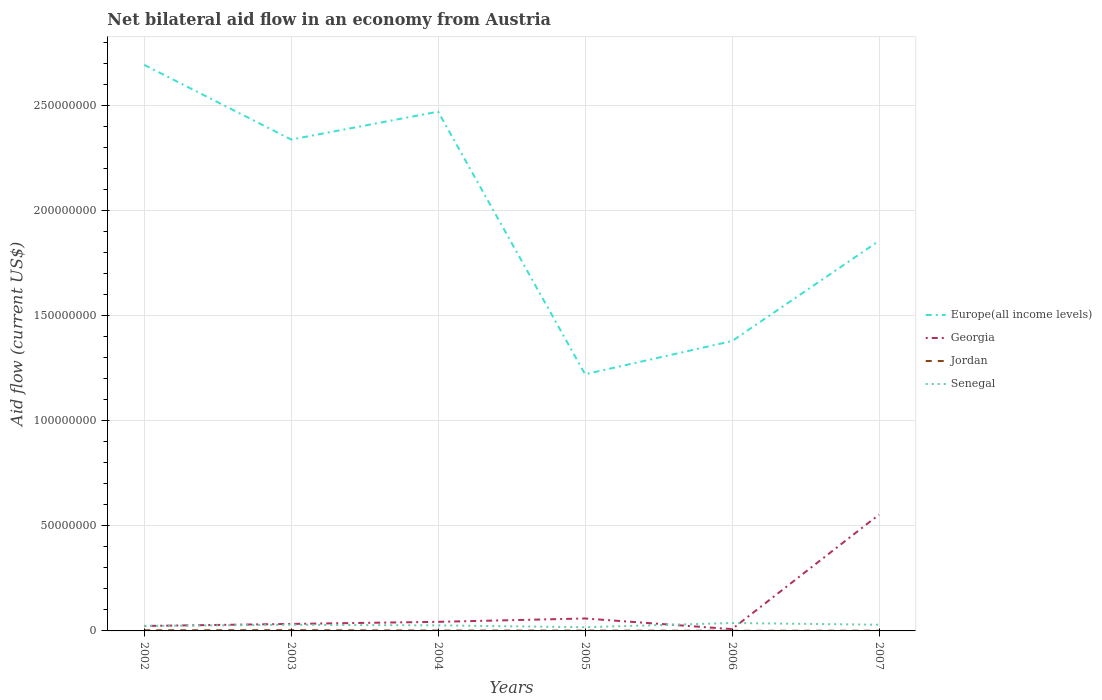Is the number of lines equal to the number of legend labels?
Your answer should be very brief. Yes. Across all years, what is the maximum net bilateral aid flow in Georgia?
Provide a short and direct response. 8.60e+05. In which year was the net bilateral aid flow in Jordan maximum?
Offer a very short reply. 2006. What is the total net bilateral aid flow in Jordan in the graph?
Keep it short and to the point. 2.10e+05. What is the difference between the highest and the second highest net bilateral aid flow in Georgia?
Make the answer very short. 5.44e+07. How many years are there in the graph?
Offer a terse response. 6. Does the graph contain grids?
Make the answer very short. Yes. What is the title of the graph?
Offer a terse response. Net bilateral aid flow in an economy from Austria. What is the Aid flow (current US$) in Europe(all income levels) in 2002?
Offer a very short reply. 2.69e+08. What is the Aid flow (current US$) of Georgia in 2002?
Your response must be concise. 2.36e+06. What is the Aid flow (current US$) in Jordan in 2002?
Make the answer very short. 3.10e+05. What is the Aid flow (current US$) in Senegal in 2002?
Your answer should be very brief. 2.36e+06. What is the Aid flow (current US$) in Europe(all income levels) in 2003?
Your response must be concise. 2.34e+08. What is the Aid flow (current US$) in Georgia in 2003?
Make the answer very short. 3.33e+06. What is the Aid flow (current US$) in Senegal in 2003?
Give a very brief answer. 2.93e+06. What is the Aid flow (current US$) of Europe(all income levels) in 2004?
Keep it short and to the point. 2.47e+08. What is the Aid flow (current US$) in Georgia in 2004?
Provide a succinct answer. 4.32e+06. What is the Aid flow (current US$) in Senegal in 2004?
Provide a succinct answer. 2.63e+06. What is the Aid flow (current US$) of Europe(all income levels) in 2005?
Make the answer very short. 1.22e+08. What is the Aid flow (current US$) of Georgia in 2005?
Keep it short and to the point. 5.92e+06. What is the Aid flow (current US$) in Senegal in 2005?
Provide a short and direct response. 1.77e+06. What is the Aid flow (current US$) in Europe(all income levels) in 2006?
Give a very brief answer. 1.38e+08. What is the Aid flow (current US$) in Georgia in 2006?
Keep it short and to the point. 8.60e+05. What is the Aid flow (current US$) of Jordan in 2006?
Offer a terse response. 7.00e+04. What is the Aid flow (current US$) of Senegal in 2006?
Your response must be concise. 3.77e+06. What is the Aid flow (current US$) of Europe(all income levels) in 2007?
Make the answer very short. 1.86e+08. What is the Aid flow (current US$) in Georgia in 2007?
Ensure brevity in your answer.  5.53e+07. What is the Aid flow (current US$) of Jordan in 2007?
Keep it short and to the point. 1.00e+05. What is the Aid flow (current US$) in Senegal in 2007?
Offer a very short reply. 2.94e+06. Across all years, what is the maximum Aid flow (current US$) of Europe(all income levels)?
Give a very brief answer. 2.69e+08. Across all years, what is the maximum Aid flow (current US$) in Georgia?
Provide a succinct answer. 5.53e+07. Across all years, what is the maximum Aid flow (current US$) of Senegal?
Offer a terse response. 3.77e+06. Across all years, what is the minimum Aid flow (current US$) of Europe(all income levels)?
Make the answer very short. 1.22e+08. Across all years, what is the minimum Aid flow (current US$) of Georgia?
Offer a very short reply. 8.60e+05. Across all years, what is the minimum Aid flow (current US$) of Jordan?
Provide a short and direct response. 7.00e+04. Across all years, what is the minimum Aid flow (current US$) of Senegal?
Your answer should be very brief. 1.77e+06. What is the total Aid flow (current US$) in Europe(all income levels) in the graph?
Provide a succinct answer. 1.20e+09. What is the total Aid flow (current US$) of Georgia in the graph?
Your answer should be compact. 7.21e+07. What is the total Aid flow (current US$) in Jordan in the graph?
Your answer should be compact. 1.17e+06. What is the total Aid flow (current US$) in Senegal in the graph?
Provide a short and direct response. 1.64e+07. What is the difference between the Aid flow (current US$) in Europe(all income levels) in 2002 and that in 2003?
Your response must be concise. 3.55e+07. What is the difference between the Aid flow (current US$) in Georgia in 2002 and that in 2003?
Provide a short and direct response. -9.70e+05. What is the difference between the Aid flow (current US$) of Senegal in 2002 and that in 2003?
Provide a short and direct response. -5.70e+05. What is the difference between the Aid flow (current US$) in Europe(all income levels) in 2002 and that in 2004?
Offer a terse response. 2.23e+07. What is the difference between the Aid flow (current US$) in Georgia in 2002 and that in 2004?
Provide a short and direct response. -1.96e+06. What is the difference between the Aid flow (current US$) in Senegal in 2002 and that in 2004?
Offer a very short reply. -2.70e+05. What is the difference between the Aid flow (current US$) in Europe(all income levels) in 2002 and that in 2005?
Offer a terse response. 1.47e+08. What is the difference between the Aid flow (current US$) of Georgia in 2002 and that in 2005?
Your response must be concise. -3.56e+06. What is the difference between the Aid flow (current US$) in Jordan in 2002 and that in 2005?
Your answer should be compact. 1.60e+05. What is the difference between the Aid flow (current US$) of Senegal in 2002 and that in 2005?
Your answer should be compact. 5.90e+05. What is the difference between the Aid flow (current US$) in Europe(all income levels) in 2002 and that in 2006?
Your answer should be very brief. 1.31e+08. What is the difference between the Aid flow (current US$) of Georgia in 2002 and that in 2006?
Provide a succinct answer. 1.50e+06. What is the difference between the Aid flow (current US$) of Senegal in 2002 and that in 2006?
Keep it short and to the point. -1.41e+06. What is the difference between the Aid flow (current US$) in Europe(all income levels) in 2002 and that in 2007?
Make the answer very short. 8.37e+07. What is the difference between the Aid flow (current US$) in Georgia in 2002 and that in 2007?
Give a very brief answer. -5.29e+07. What is the difference between the Aid flow (current US$) in Jordan in 2002 and that in 2007?
Ensure brevity in your answer.  2.10e+05. What is the difference between the Aid flow (current US$) in Senegal in 2002 and that in 2007?
Give a very brief answer. -5.80e+05. What is the difference between the Aid flow (current US$) of Europe(all income levels) in 2003 and that in 2004?
Provide a succinct answer. -1.32e+07. What is the difference between the Aid flow (current US$) in Georgia in 2003 and that in 2004?
Give a very brief answer. -9.90e+05. What is the difference between the Aid flow (current US$) of Europe(all income levels) in 2003 and that in 2005?
Offer a very short reply. 1.12e+08. What is the difference between the Aid flow (current US$) of Georgia in 2003 and that in 2005?
Offer a very short reply. -2.59e+06. What is the difference between the Aid flow (current US$) of Jordan in 2003 and that in 2005?
Your answer should be compact. 2.10e+05. What is the difference between the Aid flow (current US$) of Senegal in 2003 and that in 2005?
Your answer should be very brief. 1.16e+06. What is the difference between the Aid flow (current US$) of Europe(all income levels) in 2003 and that in 2006?
Ensure brevity in your answer.  9.59e+07. What is the difference between the Aid flow (current US$) of Georgia in 2003 and that in 2006?
Keep it short and to the point. 2.47e+06. What is the difference between the Aid flow (current US$) in Senegal in 2003 and that in 2006?
Provide a succinct answer. -8.40e+05. What is the difference between the Aid flow (current US$) of Europe(all income levels) in 2003 and that in 2007?
Your response must be concise. 4.82e+07. What is the difference between the Aid flow (current US$) in Georgia in 2003 and that in 2007?
Provide a short and direct response. -5.20e+07. What is the difference between the Aid flow (current US$) in Senegal in 2003 and that in 2007?
Give a very brief answer. -10000. What is the difference between the Aid flow (current US$) in Europe(all income levels) in 2004 and that in 2005?
Offer a very short reply. 1.25e+08. What is the difference between the Aid flow (current US$) in Georgia in 2004 and that in 2005?
Your answer should be very brief. -1.60e+06. What is the difference between the Aid flow (current US$) of Jordan in 2004 and that in 2005?
Your answer should be compact. 3.00e+04. What is the difference between the Aid flow (current US$) of Senegal in 2004 and that in 2005?
Your answer should be compact. 8.60e+05. What is the difference between the Aid flow (current US$) in Europe(all income levels) in 2004 and that in 2006?
Give a very brief answer. 1.09e+08. What is the difference between the Aid flow (current US$) in Georgia in 2004 and that in 2006?
Provide a short and direct response. 3.46e+06. What is the difference between the Aid flow (current US$) of Senegal in 2004 and that in 2006?
Provide a succinct answer. -1.14e+06. What is the difference between the Aid flow (current US$) in Europe(all income levels) in 2004 and that in 2007?
Offer a terse response. 6.15e+07. What is the difference between the Aid flow (current US$) of Georgia in 2004 and that in 2007?
Provide a succinct answer. -5.10e+07. What is the difference between the Aid flow (current US$) of Jordan in 2004 and that in 2007?
Ensure brevity in your answer.  8.00e+04. What is the difference between the Aid flow (current US$) of Senegal in 2004 and that in 2007?
Your answer should be very brief. -3.10e+05. What is the difference between the Aid flow (current US$) in Europe(all income levels) in 2005 and that in 2006?
Offer a terse response. -1.58e+07. What is the difference between the Aid flow (current US$) in Georgia in 2005 and that in 2006?
Keep it short and to the point. 5.06e+06. What is the difference between the Aid flow (current US$) in Europe(all income levels) in 2005 and that in 2007?
Your answer should be very brief. -6.34e+07. What is the difference between the Aid flow (current US$) of Georgia in 2005 and that in 2007?
Give a very brief answer. -4.94e+07. What is the difference between the Aid flow (current US$) in Jordan in 2005 and that in 2007?
Give a very brief answer. 5.00e+04. What is the difference between the Aid flow (current US$) in Senegal in 2005 and that in 2007?
Give a very brief answer. -1.17e+06. What is the difference between the Aid flow (current US$) in Europe(all income levels) in 2006 and that in 2007?
Offer a terse response. -4.76e+07. What is the difference between the Aid flow (current US$) of Georgia in 2006 and that in 2007?
Give a very brief answer. -5.44e+07. What is the difference between the Aid flow (current US$) of Jordan in 2006 and that in 2007?
Your response must be concise. -3.00e+04. What is the difference between the Aid flow (current US$) of Senegal in 2006 and that in 2007?
Your response must be concise. 8.30e+05. What is the difference between the Aid flow (current US$) in Europe(all income levels) in 2002 and the Aid flow (current US$) in Georgia in 2003?
Give a very brief answer. 2.66e+08. What is the difference between the Aid flow (current US$) in Europe(all income levels) in 2002 and the Aid flow (current US$) in Jordan in 2003?
Offer a terse response. 2.69e+08. What is the difference between the Aid flow (current US$) in Europe(all income levels) in 2002 and the Aid flow (current US$) in Senegal in 2003?
Provide a short and direct response. 2.66e+08. What is the difference between the Aid flow (current US$) of Georgia in 2002 and the Aid flow (current US$) of Senegal in 2003?
Make the answer very short. -5.70e+05. What is the difference between the Aid flow (current US$) in Jordan in 2002 and the Aid flow (current US$) in Senegal in 2003?
Your response must be concise. -2.62e+06. What is the difference between the Aid flow (current US$) in Europe(all income levels) in 2002 and the Aid flow (current US$) in Georgia in 2004?
Offer a very short reply. 2.65e+08. What is the difference between the Aid flow (current US$) of Europe(all income levels) in 2002 and the Aid flow (current US$) of Jordan in 2004?
Provide a succinct answer. 2.69e+08. What is the difference between the Aid flow (current US$) of Europe(all income levels) in 2002 and the Aid flow (current US$) of Senegal in 2004?
Offer a very short reply. 2.67e+08. What is the difference between the Aid flow (current US$) of Georgia in 2002 and the Aid flow (current US$) of Jordan in 2004?
Your response must be concise. 2.18e+06. What is the difference between the Aid flow (current US$) of Jordan in 2002 and the Aid flow (current US$) of Senegal in 2004?
Make the answer very short. -2.32e+06. What is the difference between the Aid flow (current US$) of Europe(all income levels) in 2002 and the Aid flow (current US$) of Georgia in 2005?
Your answer should be very brief. 2.63e+08. What is the difference between the Aid flow (current US$) in Europe(all income levels) in 2002 and the Aid flow (current US$) in Jordan in 2005?
Keep it short and to the point. 2.69e+08. What is the difference between the Aid flow (current US$) of Europe(all income levels) in 2002 and the Aid flow (current US$) of Senegal in 2005?
Make the answer very short. 2.67e+08. What is the difference between the Aid flow (current US$) in Georgia in 2002 and the Aid flow (current US$) in Jordan in 2005?
Your answer should be compact. 2.21e+06. What is the difference between the Aid flow (current US$) of Georgia in 2002 and the Aid flow (current US$) of Senegal in 2005?
Ensure brevity in your answer.  5.90e+05. What is the difference between the Aid flow (current US$) of Jordan in 2002 and the Aid flow (current US$) of Senegal in 2005?
Keep it short and to the point. -1.46e+06. What is the difference between the Aid flow (current US$) of Europe(all income levels) in 2002 and the Aid flow (current US$) of Georgia in 2006?
Ensure brevity in your answer.  2.68e+08. What is the difference between the Aid flow (current US$) in Europe(all income levels) in 2002 and the Aid flow (current US$) in Jordan in 2006?
Ensure brevity in your answer.  2.69e+08. What is the difference between the Aid flow (current US$) in Europe(all income levels) in 2002 and the Aid flow (current US$) in Senegal in 2006?
Offer a very short reply. 2.65e+08. What is the difference between the Aid flow (current US$) in Georgia in 2002 and the Aid flow (current US$) in Jordan in 2006?
Make the answer very short. 2.29e+06. What is the difference between the Aid flow (current US$) of Georgia in 2002 and the Aid flow (current US$) of Senegal in 2006?
Make the answer very short. -1.41e+06. What is the difference between the Aid flow (current US$) in Jordan in 2002 and the Aid flow (current US$) in Senegal in 2006?
Your answer should be very brief. -3.46e+06. What is the difference between the Aid flow (current US$) of Europe(all income levels) in 2002 and the Aid flow (current US$) of Georgia in 2007?
Keep it short and to the point. 2.14e+08. What is the difference between the Aid flow (current US$) in Europe(all income levels) in 2002 and the Aid flow (current US$) in Jordan in 2007?
Give a very brief answer. 2.69e+08. What is the difference between the Aid flow (current US$) of Europe(all income levels) in 2002 and the Aid flow (current US$) of Senegal in 2007?
Your response must be concise. 2.66e+08. What is the difference between the Aid flow (current US$) in Georgia in 2002 and the Aid flow (current US$) in Jordan in 2007?
Make the answer very short. 2.26e+06. What is the difference between the Aid flow (current US$) of Georgia in 2002 and the Aid flow (current US$) of Senegal in 2007?
Give a very brief answer. -5.80e+05. What is the difference between the Aid flow (current US$) in Jordan in 2002 and the Aid flow (current US$) in Senegal in 2007?
Make the answer very short. -2.63e+06. What is the difference between the Aid flow (current US$) of Europe(all income levels) in 2003 and the Aid flow (current US$) of Georgia in 2004?
Ensure brevity in your answer.  2.29e+08. What is the difference between the Aid flow (current US$) of Europe(all income levels) in 2003 and the Aid flow (current US$) of Jordan in 2004?
Ensure brevity in your answer.  2.34e+08. What is the difference between the Aid flow (current US$) in Europe(all income levels) in 2003 and the Aid flow (current US$) in Senegal in 2004?
Provide a succinct answer. 2.31e+08. What is the difference between the Aid flow (current US$) in Georgia in 2003 and the Aid flow (current US$) in Jordan in 2004?
Keep it short and to the point. 3.15e+06. What is the difference between the Aid flow (current US$) of Jordan in 2003 and the Aid flow (current US$) of Senegal in 2004?
Your answer should be very brief. -2.27e+06. What is the difference between the Aid flow (current US$) of Europe(all income levels) in 2003 and the Aid flow (current US$) of Georgia in 2005?
Give a very brief answer. 2.28e+08. What is the difference between the Aid flow (current US$) of Europe(all income levels) in 2003 and the Aid flow (current US$) of Jordan in 2005?
Make the answer very short. 2.34e+08. What is the difference between the Aid flow (current US$) in Europe(all income levels) in 2003 and the Aid flow (current US$) in Senegal in 2005?
Your response must be concise. 2.32e+08. What is the difference between the Aid flow (current US$) of Georgia in 2003 and the Aid flow (current US$) of Jordan in 2005?
Give a very brief answer. 3.18e+06. What is the difference between the Aid flow (current US$) of Georgia in 2003 and the Aid flow (current US$) of Senegal in 2005?
Give a very brief answer. 1.56e+06. What is the difference between the Aid flow (current US$) of Jordan in 2003 and the Aid flow (current US$) of Senegal in 2005?
Your answer should be compact. -1.41e+06. What is the difference between the Aid flow (current US$) in Europe(all income levels) in 2003 and the Aid flow (current US$) in Georgia in 2006?
Keep it short and to the point. 2.33e+08. What is the difference between the Aid flow (current US$) of Europe(all income levels) in 2003 and the Aid flow (current US$) of Jordan in 2006?
Your answer should be compact. 2.34e+08. What is the difference between the Aid flow (current US$) in Europe(all income levels) in 2003 and the Aid flow (current US$) in Senegal in 2006?
Provide a succinct answer. 2.30e+08. What is the difference between the Aid flow (current US$) in Georgia in 2003 and the Aid flow (current US$) in Jordan in 2006?
Make the answer very short. 3.26e+06. What is the difference between the Aid flow (current US$) of Georgia in 2003 and the Aid flow (current US$) of Senegal in 2006?
Your response must be concise. -4.40e+05. What is the difference between the Aid flow (current US$) in Jordan in 2003 and the Aid flow (current US$) in Senegal in 2006?
Your answer should be very brief. -3.41e+06. What is the difference between the Aid flow (current US$) of Europe(all income levels) in 2003 and the Aid flow (current US$) of Georgia in 2007?
Your answer should be very brief. 1.78e+08. What is the difference between the Aid flow (current US$) in Europe(all income levels) in 2003 and the Aid flow (current US$) in Jordan in 2007?
Ensure brevity in your answer.  2.34e+08. What is the difference between the Aid flow (current US$) in Europe(all income levels) in 2003 and the Aid flow (current US$) in Senegal in 2007?
Provide a short and direct response. 2.31e+08. What is the difference between the Aid flow (current US$) in Georgia in 2003 and the Aid flow (current US$) in Jordan in 2007?
Provide a succinct answer. 3.23e+06. What is the difference between the Aid flow (current US$) of Georgia in 2003 and the Aid flow (current US$) of Senegal in 2007?
Provide a short and direct response. 3.90e+05. What is the difference between the Aid flow (current US$) of Jordan in 2003 and the Aid flow (current US$) of Senegal in 2007?
Keep it short and to the point. -2.58e+06. What is the difference between the Aid flow (current US$) of Europe(all income levels) in 2004 and the Aid flow (current US$) of Georgia in 2005?
Make the answer very short. 2.41e+08. What is the difference between the Aid flow (current US$) in Europe(all income levels) in 2004 and the Aid flow (current US$) in Jordan in 2005?
Make the answer very short. 2.47e+08. What is the difference between the Aid flow (current US$) of Europe(all income levels) in 2004 and the Aid flow (current US$) of Senegal in 2005?
Provide a short and direct response. 2.45e+08. What is the difference between the Aid flow (current US$) in Georgia in 2004 and the Aid flow (current US$) in Jordan in 2005?
Keep it short and to the point. 4.17e+06. What is the difference between the Aid flow (current US$) of Georgia in 2004 and the Aid flow (current US$) of Senegal in 2005?
Keep it short and to the point. 2.55e+06. What is the difference between the Aid flow (current US$) in Jordan in 2004 and the Aid flow (current US$) in Senegal in 2005?
Offer a very short reply. -1.59e+06. What is the difference between the Aid flow (current US$) in Europe(all income levels) in 2004 and the Aid flow (current US$) in Georgia in 2006?
Give a very brief answer. 2.46e+08. What is the difference between the Aid flow (current US$) of Europe(all income levels) in 2004 and the Aid flow (current US$) of Jordan in 2006?
Offer a very short reply. 2.47e+08. What is the difference between the Aid flow (current US$) of Europe(all income levels) in 2004 and the Aid flow (current US$) of Senegal in 2006?
Make the answer very short. 2.43e+08. What is the difference between the Aid flow (current US$) in Georgia in 2004 and the Aid flow (current US$) in Jordan in 2006?
Your answer should be very brief. 4.25e+06. What is the difference between the Aid flow (current US$) of Georgia in 2004 and the Aid flow (current US$) of Senegal in 2006?
Your answer should be very brief. 5.50e+05. What is the difference between the Aid flow (current US$) in Jordan in 2004 and the Aid flow (current US$) in Senegal in 2006?
Offer a terse response. -3.59e+06. What is the difference between the Aid flow (current US$) in Europe(all income levels) in 2004 and the Aid flow (current US$) in Georgia in 2007?
Provide a succinct answer. 1.92e+08. What is the difference between the Aid flow (current US$) in Europe(all income levels) in 2004 and the Aid flow (current US$) in Jordan in 2007?
Provide a short and direct response. 2.47e+08. What is the difference between the Aid flow (current US$) in Europe(all income levels) in 2004 and the Aid flow (current US$) in Senegal in 2007?
Keep it short and to the point. 2.44e+08. What is the difference between the Aid flow (current US$) in Georgia in 2004 and the Aid flow (current US$) in Jordan in 2007?
Provide a short and direct response. 4.22e+06. What is the difference between the Aid flow (current US$) in Georgia in 2004 and the Aid flow (current US$) in Senegal in 2007?
Give a very brief answer. 1.38e+06. What is the difference between the Aid flow (current US$) in Jordan in 2004 and the Aid flow (current US$) in Senegal in 2007?
Your response must be concise. -2.76e+06. What is the difference between the Aid flow (current US$) of Europe(all income levels) in 2005 and the Aid flow (current US$) of Georgia in 2006?
Provide a short and direct response. 1.21e+08. What is the difference between the Aid flow (current US$) in Europe(all income levels) in 2005 and the Aid flow (current US$) in Jordan in 2006?
Provide a succinct answer. 1.22e+08. What is the difference between the Aid flow (current US$) in Europe(all income levels) in 2005 and the Aid flow (current US$) in Senegal in 2006?
Offer a terse response. 1.18e+08. What is the difference between the Aid flow (current US$) of Georgia in 2005 and the Aid flow (current US$) of Jordan in 2006?
Your response must be concise. 5.85e+06. What is the difference between the Aid flow (current US$) in Georgia in 2005 and the Aid flow (current US$) in Senegal in 2006?
Your answer should be compact. 2.15e+06. What is the difference between the Aid flow (current US$) in Jordan in 2005 and the Aid flow (current US$) in Senegal in 2006?
Offer a very short reply. -3.62e+06. What is the difference between the Aid flow (current US$) in Europe(all income levels) in 2005 and the Aid flow (current US$) in Georgia in 2007?
Your answer should be very brief. 6.68e+07. What is the difference between the Aid flow (current US$) of Europe(all income levels) in 2005 and the Aid flow (current US$) of Jordan in 2007?
Provide a succinct answer. 1.22e+08. What is the difference between the Aid flow (current US$) of Europe(all income levels) in 2005 and the Aid flow (current US$) of Senegal in 2007?
Your answer should be compact. 1.19e+08. What is the difference between the Aid flow (current US$) of Georgia in 2005 and the Aid flow (current US$) of Jordan in 2007?
Your answer should be compact. 5.82e+06. What is the difference between the Aid flow (current US$) in Georgia in 2005 and the Aid flow (current US$) in Senegal in 2007?
Offer a very short reply. 2.98e+06. What is the difference between the Aid flow (current US$) in Jordan in 2005 and the Aid flow (current US$) in Senegal in 2007?
Your response must be concise. -2.79e+06. What is the difference between the Aid flow (current US$) of Europe(all income levels) in 2006 and the Aid flow (current US$) of Georgia in 2007?
Your answer should be very brief. 8.26e+07. What is the difference between the Aid flow (current US$) of Europe(all income levels) in 2006 and the Aid flow (current US$) of Jordan in 2007?
Offer a terse response. 1.38e+08. What is the difference between the Aid flow (current US$) of Europe(all income levels) in 2006 and the Aid flow (current US$) of Senegal in 2007?
Make the answer very short. 1.35e+08. What is the difference between the Aid flow (current US$) of Georgia in 2006 and the Aid flow (current US$) of Jordan in 2007?
Offer a terse response. 7.60e+05. What is the difference between the Aid flow (current US$) in Georgia in 2006 and the Aid flow (current US$) in Senegal in 2007?
Make the answer very short. -2.08e+06. What is the difference between the Aid flow (current US$) of Jordan in 2006 and the Aid flow (current US$) of Senegal in 2007?
Your answer should be very brief. -2.87e+06. What is the average Aid flow (current US$) of Europe(all income levels) per year?
Ensure brevity in your answer.  1.99e+08. What is the average Aid flow (current US$) of Georgia per year?
Your answer should be compact. 1.20e+07. What is the average Aid flow (current US$) of Jordan per year?
Give a very brief answer. 1.95e+05. What is the average Aid flow (current US$) in Senegal per year?
Your response must be concise. 2.73e+06. In the year 2002, what is the difference between the Aid flow (current US$) in Europe(all income levels) and Aid flow (current US$) in Georgia?
Provide a succinct answer. 2.67e+08. In the year 2002, what is the difference between the Aid flow (current US$) in Europe(all income levels) and Aid flow (current US$) in Jordan?
Ensure brevity in your answer.  2.69e+08. In the year 2002, what is the difference between the Aid flow (current US$) of Europe(all income levels) and Aid flow (current US$) of Senegal?
Provide a succinct answer. 2.67e+08. In the year 2002, what is the difference between the Aid flow (current US$) in Georgia and Aid flow (current US$) in Jordan?
Offer a very short reply. 2.05e+06. In the year 2002, what is the difference between the Aid flow (current US$) in Jordan and Aid flow (current US$) in Senegal?
Ensure brevity in your answer.  -2.05e+06. In the year 2003, what is the difference between the Aid flow (current US$) of Europe(all income levels) and Aid flow (current US$) of Georgia?
Offer a very short reply. 2.30e+08. In the year 2003, what is the difference between the Aid flow (current US$) in Europe(all income levels) and Aid flow (current US$) in Jordan?
Your answer should be very brief. 2.33e+08. In the year 2003, what is the difference between the Aid flow (current US$) in Europe(all income levels) and Aid flow (current US$) in Senegal?
Make the answer very short. 2.31e+08. In the year 2003, what is the difference between the Aid flow (current US$) of Georgia and Aid flow (current US$) of Jordan?
Your answer should be compact. 2.97e+06. In the year 2003, what is the difference between the Aid flow (current US$) in Jordan and Aid flow (current US$) in Senegal?
Offer a terse response. -2.57e+06. In the year 2004, what is the difference between the Aid flow (current US$) of Europe(all income levels) and Aid flow (current US$) of Georgia?
Your answer should be very brief. 2.43e+08. In the year 2004, what is the difference between the Aid flow (current US$) in Europe(all income levels) and Aid flow (current US$) in Jordan?
Offer a very short reply. 2.47e+08. In the year 2004, what is the difference between the Aid flow (current US$) of Europe(all income levels) and Aid flow (current US$) of Senegal?
Your answer should be compact. 2.44e+08. In the year 2004, what is the difference between the Aid flow (current US$) of Georgia and Aid flow (current US$) of Jordan?
Offer a terse response. 4.14e+06. In the year 2004, what is the difference between the Aid flow (current US$) in Georgia and Aid flow (current US$) in Senegal?
Offer a very short reply. 1.69e+06. In the year 2004, what is the difference between the Aid flow (current US$) of Jordan and Aid flow (current US$) of Senegal?
Ensure brevity in your answer.  -2.45e+06. In the year 2005, what is the difference between the Aid flow (current US$) of Europe(all income levels) and Aid flow (current US$) of Georgia?
Provide a succinct answer. 1.16e+08. In the year 2005, what is the difference between the Aid flow (current US$) in Europe(all income levels) and Aid flow (current US$) in Jordan?
Provide a succinct answer. 1.22e+08. In the year 2005, what is the difference between the Aid flow (current US$) in Europe(all income levels) and Aid flow (current US$) in Senegal?
Your answer should be very brief. 1.20e+08. In the year 2005, what is the difference between the Aid flow (current US$) of Georgia and Aid flow (current US$) of Jordan?
Ensure brevity in your answer.  5.77e+06. In the year 2005, what is the difference between the Aid flow (current US$) in Georgia and Aid flow (current US$) in Senegal?
Make the answer very short. 4.15e+06. In the year 2005, what is the difference between the Aid flow (current US$) of Jordan and Aid flow (current US$) of Senegal?
Your answer should be very brief. -1.62e+06. In the year 2006, what is the difference between the Aid flow (current US$) of Europe(all income levels) and Aid flow (current US$) of Georgia?
Provide a short and direct response. 1.37e+08. In the year 2006, what is the difference between the Aid flow (current US$) of Europe(all income levels) and Aid flow (current US$) of Jordan?
Keep it short and to the point. 1.38e+08. In the year 2006, what is the difference between the Aid flow (current US$) in Europe(all income levels) and Aid flow (current US$) in Senegal?
Offer a terse response. 1.34e+08. In the year 2006, what is the difference between the Aid flow (current US$) of Georgia and Aid flow (current US$) of Jordan?
Ensure brevity in your answer.  7.90e+05. In the year 2006, what is the difference between the Aid flow (current US$) of Georgia and Aid flow (current US$) of Senegal?
Offer a very short reply. -2.91e+06. In the year 2006, what is the difference between the Aid flow (current US$) of Jordan and Aid flow (current US$) of Senegal?
Ensure brevity in your answer.  -3.70e+06. In the year 2007, what is the difference between the Aid flow (current US$) in Europe(all income levels) and Aid flow (current US$) in Georgia?
Make the answer very short. 1.30e+08. In the year 2007, what is the difference between the Aid flow (current US$) of Europe(all income levels) and Aid flow (current US$) of Jordan?
Keep it short and to the point. 1.85e+08. In the year 2007, what is the difference between the Aid flow (current US$) in Europe(all income levels) and Aid flow (current US$) in Senegal?
Offer a very short reply. 1.83e+08. In the year 2007, what is the difference between the Aid flow (current US$) of Georgia and Aid flow (current US$) of Jordan?
Provide a succinct answer. 5.52e+07. In the year 2007, what is the difference between the Aid flow (current US$) in Georgia and Aid flow (current US$) in Senegal?
Make the answer very short. 5.24e+07. In the year 2007, what is the difference between the Aid flow (current US$) in Jordan and Aid flow (current US$) in Senegal?
Your response must be concise. -2.84e+06. What is the ratio of the Aid flow (current US$) of Europe(all income levels) in 2002 to that in 2003?
Keep it short and to the point. 1.15. What is the ratio of the Aid flow (current US$) in Georgia in 2002 to that in 2003?
Make the answer very short. 0.71. What is the ratio of the Aid flow (current US$) of Jordan in 2002 to that in 2003?
Provide a short and direct response. 0.86. What is the ratio of the Aid flow (current US$) of Senegal in 2002 to that in 2003?
Offer a very short reply. 0.81. What is the ratio of the Aid flow (current US$) of Europe(all income levels) in 2002 to that in 2004?
Ensure brevity in your answer.  1.09. What is the ratio of the Aid flow (current US$) in Georgia in 2002 to that in 2004?
Give a very brief answer. 0.55. What is the ratio of the Aid flow (current US$) in Jordan in 2002 to that in 2004?
Provide a short and direct response. 1.72. What is the ratio of the Aid flow (current US$) of Senegal in 2002 to that in 2004?
Offer a terse response. 0.9. What is the ratio of the Aid flow (current US$) in Europe(all income levels) in 2002 to that in 2005?
Your answer should be compact. 2.21. What is the ratio of the Aid flow (current US$) of Georgia in 2002 to that in 2005?
Provide a short and direct response. 0.4. What is the ratio of the Aid flow (current US$) in Jordan in 2002 to that in 2005?
Provide a succinct answer. 2.07. What is the ratio of the Aid flow (current US$) of Senegal in 2002 to that in 2005?
Offer a very short reply. 1.33. What is the ratio of the Aid flow (current US$) in Europe(all income levels) in 2002 to that in 2006?
Your answer should be compact. 1.95. What is the ratio of the Aid flow (current US$) in Georgia in 2002 to that in 2006?
Provide a short and direct response. 2.74. What is the ratio of the Aid flow (current US$) of Jordan in 2002 to that in 2006?
Provide a short and direct response. 4.43. What is the ratio of the Aid flow (current US$) of Senegal in 2002 to that in 2006?
Give a very brief answer. 0.63. What is the ratio of the Aid flow (current US$) of Europe(all income levels) in 2002 to that in 2007?
Make the answer very short. 1.45. What is the ratio of the Aid flow (current US$) in Georgia in 2002 to that in 2007?
Keep it short and to the point. 0.04. What is the ratio of the Aid flow (current US$) of Jordan in 2002 to that in 2007?
Offer a terse response. 3.1. What is the ratio of the Aid flow (current US$) in Senegal in 2002 to that in 2007?
Offer a terse response. 0.8. What is the ratio of the Aid flow (current US$) in Europe(all income levels) in 2003 to that in 2004?
Offer a terse response. 0.95. What is the ratio of the Aid flow (current US$) in Georgia in 2003 to that in 2004?
Offer a terse response. 0.77. What is the ratio of the Aid flow (current US$) of Jordan in 2003 to that in 2004?
Ensure brevity in your answer.  2. What is the ratio of the Aid flow (current US$) of Senegal in 2003 to that in 2004?
Your answer should be very brief. 1.11. What is the ratio of the Aid flow (current US$) of Europe(all income levels) in 2003 to that in 2005?
Your answer should be very brief. 1.91. What is the ratio of the Aid flow (current US$) in Georgia in 2003 to that in 2005?
Keep it short and to the point. 0.56. What is the ratio of the Aid flow (current US$) in Senegal in 2003 to that in 2005?
Give a very brief answer. 1.66. What is the ratio of the Aid flow (current US$) of Europe(all income levels) in 2003 to that in 2006?
Provide a short and direct response. 1.7. What is the ratio of the Aid flow (current US$) of Georgia in 2003 to that in 2006?
Provide a succinct answer. 3.87. What is the ratio of the Aid flow (current US$) in Jordan in 2003 to that in 2006?
Your answer should be compact. 5.14. What is the ratio of the Aid flow (current US$) of Senegal in 2003 to that in 2006?
Provide a succinct answer. 0.78. What is the ratio of the Aid flow (current US$) of Europe(all income levels) in 2003 to that in 2007?
Your answer should be very brief. 1.26. What is the ratio of the Aid flow (current US$) in Georgia in 2003 to that in 2007?
Your response must be concise. 0.06. What is the ratio of the Aid flow (current US$) in Jordan in 2003 to that in 2007?
Your response must be concise. 3.6. What is the ratio of the Aid flow (current US$) of Europe(all income levels) in 2004 to that in 2005?
Your response must be concise. 2.02. What is the ratio of the Aid flow (current US$) in Georgia in 2004 to that in 2005?
Keep it short and to the point. 0.73. What is the ratio of the Aid flow (current US$) in Jordan in 2004 to that in 2005?
Give a very brief answer. 1.2. What is the ratio of the Aid flow (current US$) of Senegal in 2004 to that in 2005?
Make the answer very short. 1.49. What is the ratio of the Aid flow (current US$) of Europe(all income levels) in 2004 to that in 2006?
Give a very brief answer. 1.79. What is the ratio of the Aid flow (current US$) in Georgia in 2004 to that in 2006?
Make the answer very short. 5.02. What is the ratio of the Aid flow (current US$) of Jordan in 2004 to that in 2006?
Ensure brevity in your answer.  2.57. What is the ratio of the Aid flow (current US$) of Senegal in 2004 to that in 2006?
Provide a short and direct response. 0.7. What is the ratio of the Aid flow (current US$) of Europe(all income levels) in 2004 to that in 2007?
Give a very brief answer. 1.33. What is the ratio of the Aid flow (current US$) in Georgia in 2004 to that in 2007?
Give a very brief answer. 0.08. What is the ratio of the Aid flow (current US$) of Jordan in 2004 to that in 2007?
Offer a very short reply. 1.8. What is the ratio of the Aid flow (current US$) of Senegal in 2004 to that in 2007?
Your response must be concise. 0.89. What is the ratio of the Aid flow (current US$) in Europe(all income levels) in 2005 to that in 2006?
Make the answer very short. 0.89. What is the ratio of the Aid flow (current US$) in Georgia in 2005 to that in 2006?
Provide a short and direct response. 6.88. What is the ratio of the Aid flow (current US$) in Jordan in 2005 to that in 2006?
Provide a short and direct response. 2.14. What is the ratio of the Aid flow (current US$) of Senegal in 2005 to that in 2006?
Offer a very short reply. 0.47. What is the ratio of the Aid flow (current US$) of Europe(all income levels) in 2005 to that in 2007?
Your answer should be very brief. 0.66. What is the ratio of the Aid flow (current US$) of Georgia in 2005 to that in 2007?
Give a very brief answer. 0.11. What is the ratio of the Aid flow (current US$) of Senegal in 2005 to that in 2007?
Your response must be concise. 0.6. What is the ratio of the Aid flow (current US$) of Europe(all income levels) in 2006 to that in 2007?
Make the answer very short. 0.74. What is the ratio of the Aid flow (current US$) of Georgia in 2006 to that in 2007?
Ensure brevity in your answer.  0.02. What is the ratio of the Aid flow (current US$) in Senegal in 2006 to that in 2007?
Make the answer very short. 1.28. What is the difference between the highest and the second highest Aid flow (current US$) of Europe(all income levels)?
Your answer should be compact. 2.23e+07. What is the difference between the highest and the second highest Aid flow (current US$) of Georgia?
Offer a very short reply. 4.94e+07. What is the difference between the highest and the second highest Aid flow (current US$) in Senegal?
Keep it short and to the point. 8.30e+05. What is the difference between the highest and the lowest Aid flow (current US$) in Europe(all income levels)?
Make the answer very short. 1.47e+08. What is the difference between the highest and the lowest Aid flow (current US$) of Georgia?
Ensure brevity in your answer.  5.44e+07. 